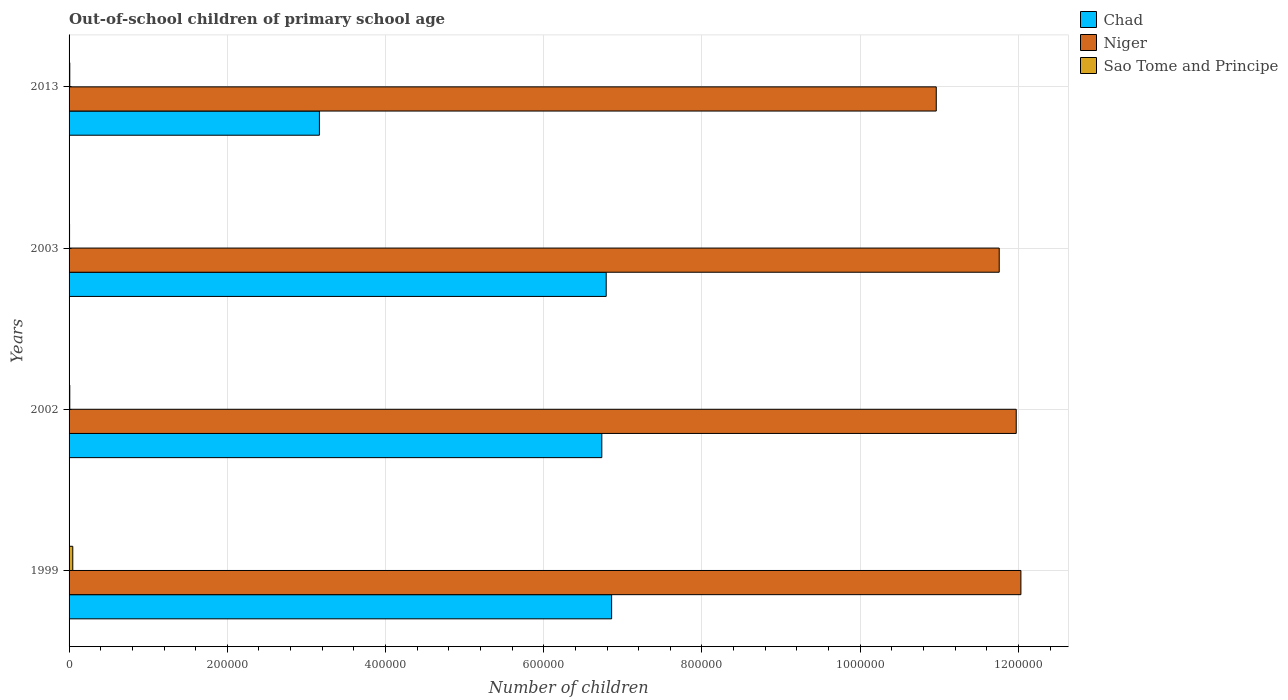How many different coloured bars are there?
Your answer should be compact. 3. What is the label of the 1st group of bars from the top?
Make the answer very short. 2013. In how many cases, is the number of bars for a given year not equal to the number of legend labels?
Offer a terse response. 0. What is the number of out-of-school children in Chad in 2003?
Provide a succinct answer. 6.79e+05. Across all years, what is the maximum number of out-of-school children in Sao Tome and Principe?
Make the answer very short. 4698. Across all years, what is the minimum number of out-of-school children in Sao Tome and Principe?
Your response must be concise. 627. What is the total number of out-of-school children in Sao Tome and Principe in the graph?
Give a very brief answer. 7118. What is the difference between the number of out-of-school children in Sao Tome and Principe in 2003 and that in 2013?
Ensure brevity in your answer.  -271. What is the difference between the number of out-of-school children in Niger in 2013 and the number of out-of-school children in Chad in 1999?
Your answer should be compact. 4.10e+05. What is the average number of out-of-school children in Sao Tome and Principe per year?
Your response must be concise. 1779.5. In the year 2013, what is the difference between the number of out-of-school children in Sao Tome and Principe and number of out-of-school children in Niger?
Ensure brevity in your answer.  -1.10e+06. What is the ratio of the number of out-of-school children in Niger in 1999 to that in 2003?
Ensure brevity in your answer.  1.02. Is the number of out-of-school children in Sao Tome and Principe in 2003 less than that in 2013?
Give a very brief answer. Yes. What is the difference between the highest and the second highest number of out-of-school children in Niger?
Your answer should be compact. 5892. What is the difference between the highest and the lowest number of out-of-school children in Niger?
Your answer should be very brief. 1.07e+05. In how many years, is the number of out-of-school children in Sao Tome and Principe greater than the average number of out-of-school children in Sao Tome and Principe taken over all years?
Offer a terse response. 1. What does the 3rd bar from the top in 1999 represents?
Keep it short and to the point. Chad. What does the 2nd bar from the bottom in 2003 represents?
Keep it short and to the point. Niger. Is it the case that in every year, the sum of the number of out-of-school children in Niger and number of out-of-school children in Chad is greater than the number of out-of-school children in Sao Tome and Principe?
Provide a succinct answer. Yes. How many years are there in the graph?
Provide a succinct answer. 4. What is the difference between two consecutive major ticks on the X-axis?
Offer a very short reply. 2.00e+05. Are the values on the major ticks of X-axis written in scientific E-notation?
Provide a short and direct response. No. Does the graph contain any zero values?
Your answer should be very brief. No. Does the graph contain grids?
Ensure brevity in your answer.  Yes. Where does the legend appear in the graph?
Your answer should be compact. Top right. How are the legend labels stacked?
Make the answer very short. Vertical. What is the title of the graph?
Give a very brief answer. Out-of-school children of primary school age. What is the label or title of the X-axis?
Your answer should be very brief. Number of children. What is the Number of children in Chad in 1999?
Ensure brevity in your answer.  6.86e+05. What is the Number of children in Niger in 1999?
Give a very brief answer. 1.20e+06. What is the Number of children of Sao Tome and Principe in 1999?
Your response must be concise. 4698. What is the Number of children of Chad in 2002?
Give a very brief answer. 6.73e+05. What is the Number of children in Niger in 2002?
Your response must be concise. 1.20e+06. What is the Number of children of Sao Tome and Principe in 2002?
Ensure brevity in your answer.  895. What is the Number of children in Chad in 2003?
Provide a succinct answer. 6.79e+05. What is the Number of children in Niger in 2003?
Your answer should be very brief. 1.18e+06. What is the Number of children of Sao Tome and Principe in 2003?
Make the answer very short. 627. What is the Number of children of Chad in 2013?
Your response must be concise. 3.16e+05. What is the Number of children of Niger in 2013?
Your answer should be compact. 1.10e+06. What is the Number of children of Sao Tome and Principe in 2013?
Keep it short and to the point. 898. Across all years, what is the maximum Number of children of Chad?
Provide a short and direct response. 6.86e+05. Across all years, what is the maximum Number of children of Niger?
Keep it short and to the point. 1.20e+06. Across all years, what is the maximum Number of children of Sao Tome and Principe?
Offer a terse response. 4698. Across all years, what is the minimum Number of children of Chad?
Make the answer very short. 3.16e+05. Across all years, what is the minimum Number of children in Niger?
Your response must be concise. 1.10e+06. Across all years, what is the minimum Number of children in Sao Tome and Principe?
Your answer should be very brief. 627. What is the total Number of children in Chad in the graph?
Offer a very short reply. 2.35e+06. What is the total Number of children in Niger in the graph?
Give a very brief answer. 4.67e+06. What is the total Number of children in Sao Tome and Principe in the graph?
Your answer should be very brief. 7118. What is the difference between the Number of children in Chad in 1999 and that in 2002?
Make the answer very short. 1.24e+04. What is the difference between the Number of children of Niger in 1999 and that in 2002?
Give a very brief answer. 5892. What is the difference between the Number of children of Sao Tome and Principe in 1999 and that in 2002?
Ensure brevity in your answer.  3803. What is the difference between the Number of children of Chad in 1999 and that in 2003?
Keep it short and to the point. 6868. What is the difference between the Number of children of Niger in 1999 and that in 2003?
Provide a short and direct response. 2.74e+04. What is the difference between the Number of children in Sao Tome and Principe in 1999 and that in 2003?
Provide a succinct answer. 4071. What is the difference between the Number of children of Chad in 1999 and that in 2013?
Offer a very short reply. 3.69e+05. What is the difference between the Number of children in Niger in 1999 and that in 2013?
Your answer should be very brief. 1.07e+05. What is the difference between the Number of children in Sao Tome and Principe in 1999 and that in 2013?
Your answer should be compact. 3800. What is the difference between the Number of children of Chad in 2002 and that in 2003?
Ensure brevity in your answer.  -5535. What is the difference between the Number of children of Niger in 2002 and that in 2003?
Keep it short and to the point. 2.15e+04. What is the difference between the Number of children of Sao Tome and Principe in 2002 and that in 2003?
Provide a short and direct response. 268. What is the difference between the Number of children in Chad in 2002 and that in 2013?
Your answer should be very brief. 3.57e+05. What is the difference between the Number of children in Niger in 2002 and that in 2013?
Provide a short and direct response. 1.01e+05. What is the difference between the Number of children in Chad in 2003 and that in 2013?
Keep it short and to the point. 3.63e+05. What is the difference between the Number of children of Niger in 2003 and that in 2013?
Give a very brief answer. 7.96e+04. What is the difference between the Number of children in Sao Tome and Principe in 2003 and that in 2013?
Give a very brief answer. -271. What is the difference between the Number of children in Chad in 1999 and the Number of children in Niger in 2002?
Your response must be concise. -5.11e+05. What is the difference between the Number of children in Chad in 1999 and the Number of children in Sao Tome and Principe in 2002?
Provide a short and direct response. 6.85e+05. What is the difference between the Number of children of Niger in 1999 and the Number of children of Sao Tome and Principe in 2002?
Offer a very short reply. 1.20e+06. What is the difference between the Number of children in Chad in 1999 and the Number of children in Niger in 2003?
Ensure brevity in your answer.  -4.90e+05. What is the difference between the Number of children of Chad in 1999 and the Number of children of Sao Tome and Principe in 2003?
Offer a terse response. 6.85e+05. What is the difference between the Number of children of Niger in 1999 and the Number of children of Sao Tome and Principe in 2003?
Your answer should be very brief. 1.20e+06. What is the difference between the Number of children of Chad in 1999 and the Number of children of Niger in 2013?
Offer a very short reply. -4.10e+05. What is the difference between the Number of children of Chad in 1999 and the Number of children of Sao Tome and Principe in 2013?
Provide a short and direct response. 6.85e+05. What is the difference between the Number of children in Niger in 1999 and the Number of children in Sao Tome and Principe in 2013?
Keep it short and to the point. 1.20e+06. What is the difference between the Number of children of Chad in 2002 and the Number of children of Niger in 2003?
Give a very brief answer. -5.02e+05. What is the difference between the Number of children in Chad in 2002 and the Number of children in Sao Tome and Principe in 2003?
Your answer should be compact. 6.73e+05. What is the difference between the Number of children of Niger in 2002 and the Number of children of Sao Tome and Principe in 2003?
Offer a very short reply. 1.20e+06. What is the difference between the Number of children of Chad in 2002 and the Number of children of Niger in 2013?
Offer a terse response. -4.23e+05. What is the difference between the Number of children in Chad in 2002 and the Number of children in Sao Tome and Principe in 2013?
Your answer should be compact. 6.73e+05. What is the difference between the Number of children in Niger in 2002 and the Number of children in Sao Tome and Principe in 2013?
Ensure brevity in your answer.  1.20e+06. What is the difference between the Number of children in Chad in 2003 and the Number of children in Niger in 2013?
Offer a terse response. -4.17e+05. What is the difference between the Number of children in Chad in 2003 and the Number of children in Sao Tome and Principe in 2013?
Your response must be concise. 6.78e+05. What is the difference between the Number of children of Niger in 2003 and the Number of children of Sao Tome and Principe in 2013?
Your answer should be compact. 1.17e+06. What is the average Number of children of Chad per year?
Give a very brief answer. 5.89e+05. What is the average Number of children of Niger per year?
Your answer should be very brief. 1.17e+06. What is the average Number of children in Sao Tome and Principe per year?
Offer a terse response. 1779.5. In the year 1999, what is the difference between the Number of children in Chad and Number of children in Niger?
Provide a short and direct response. -5.17e+05. In the year 1999, what is the difference between the Number of children of Chad and Number of children of Sao Tome and Principe?
Provide a short and direct response. 6.81e+05. In the year 1999, what is the difference between the Number of children in Niger and Number of children in Sao Tome and Principe?
Offer a terse response. 1.20e+06. In the year 2002, what is the difference between the Number of children of Chad and Number of children of Niger?
Provide a succinct answer. -5.24e+05. In the year 2002, what is the difference between the Number of children in Chad and Number of children in Sao Tome and Principe?
Offer a terse response. 6.73e+05. In the year 2002, what is the difference between the Number of children of Niger and Number of children of Sao Tome and Principe?
Your response must be concise. 1.20e+06. In the year 2003, what is the difference between the Number of children in Chad and Number of children in Niger?
Make the answer very short. -4.97e+05. In the year 2003, what is the difference between the Number of children in Chad and Number of children in Sao Tome and Principe?
Offer a very short reply. 6.78e+05. In the year 2003, what is the difference between the Number of children in Niger and Number of children in Sao Tome and Principe?
Your answer should be very brief. 1.18e+06. In the year 2013, what is the difference between the Number of children of Chad and Number of children of Niger?
Your answer should be compact. -7.80e+05. In the year 2013, what is the difference between the Number of children in Chad and Number of children in Sao Tome and Principe?
Your answer should be compact. 3.16e+05. In the year 2013, what is the difference between the Number of children of Niger and Number of children of Sao Tome and Principe?
Offer a very short reply. 1.10e+06. What is the ratio of the Number of children in Chad in 1999 to that in 2002?
Your answer should be very brief. 1.02. What is the ratio of the Number of children in Sao Tome and Principe in 1999 to that in 2002?
Ensure brevity in your answer.  5.25. What is the ratio of the Number of children in Chad in 1999 to that in 2003?
Provide a succinct answer. 1.01. What is the ratio of the Number of children in Niger in 1999 to that in 2003?
Make the answer very short. 1.02. What is the ratio of the Number of children in Sao Tome and Principe in 1999 to that in 2003?
Offer a terse response. 7.49. What is the ratio of the Number of children in Chad in 1999 to that in 2013?
Keep it short and to the point. 2.17. What is the ratio of the Number of children of Niger in 1999 to that in 2013?
Offer a very short reply. 1.1. What is the ratio of the Number of children in Sao Tome and Principe in 1999 to that in 2013?
Give a very brief answer. 5.23. What is the ratio of the Number of children of Chad in 2002 to that in 2003?
Offer a terse response. 0.99. What is the ratio of the Number of children of Niger in 2002 to that in 2003?
Offer a very short reply. 1.02. What is the ratio of the Number of children of Sao Tome and Principe in 2002 to that in 2003?
Keep it short and to the point. 1.43. What is the ratio of the Number of children in Chad in 2002 to that in 2013?
Provide a succinct answer. 2.13. What is the ratio of the Number of children of Niger in 2002 to that in 2013?
Provide a succinct answer. 1.09. What is the ratio of the Number of children in Chad in 2003 to that in 2013?
Give a very brief answer. 2.15. What is the ratio of the Number of children of Niger in 2003 to that in 2013?
Offer a terse response. 1.07. What is the ratio of the Number of children in Sao Tome and Principe in 2003 to that in 2013?
Your answer should be compact. 0.7. What is the difference between the highest and the second highest Number of children in Chad?
Make the answer very short. 6868. What is the difference between the highest and the second highest Number of children of Niger?
Give a very brief answer. 5892. What is the difference between the highest and the second highest Number of children of Sao Tome and Principe?
Provide a short and direct response. 3800. What is the difference between the highest and the lowest Number of children of Chad?
Provide a short and direct response. 3.69e+05. What is the difference between the highest and the lowest Number of children of Niger?
Your answer should be very brief. 1.07e+05. What is the difference between the highest and the lowest Number of children of Sao Tome and Principe?
Ensure brevity in your answer.  4071. 